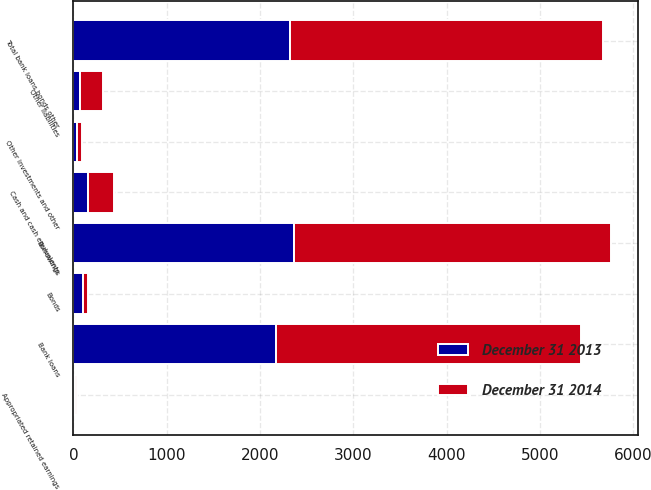<chart> <loc_0><loc_0><loc_500><loc_500><stacked_bar_chart><ecel><fcel>Cash and cash equivalents<fcel>Bank loans<fcel>Bonds<fcel>Other investments and other<fcel>Total bank loans bonds other<fcel>Borrowings<fcel>Other liabilities<fcel>Appropriated retained earnings<nl><fcel>December 31 2014<fcel>278<fcel>3260<fcel>47<fcel>45<fcel>3352<fcel>3389<fcel>245<fcel>19<nl><fcel>December 31 2013<fcel>161<fcel>2176<fcel>106<fcel>43<fcel>2325<fcel>2369<fcel>74<fcel>22<nl></chart> 